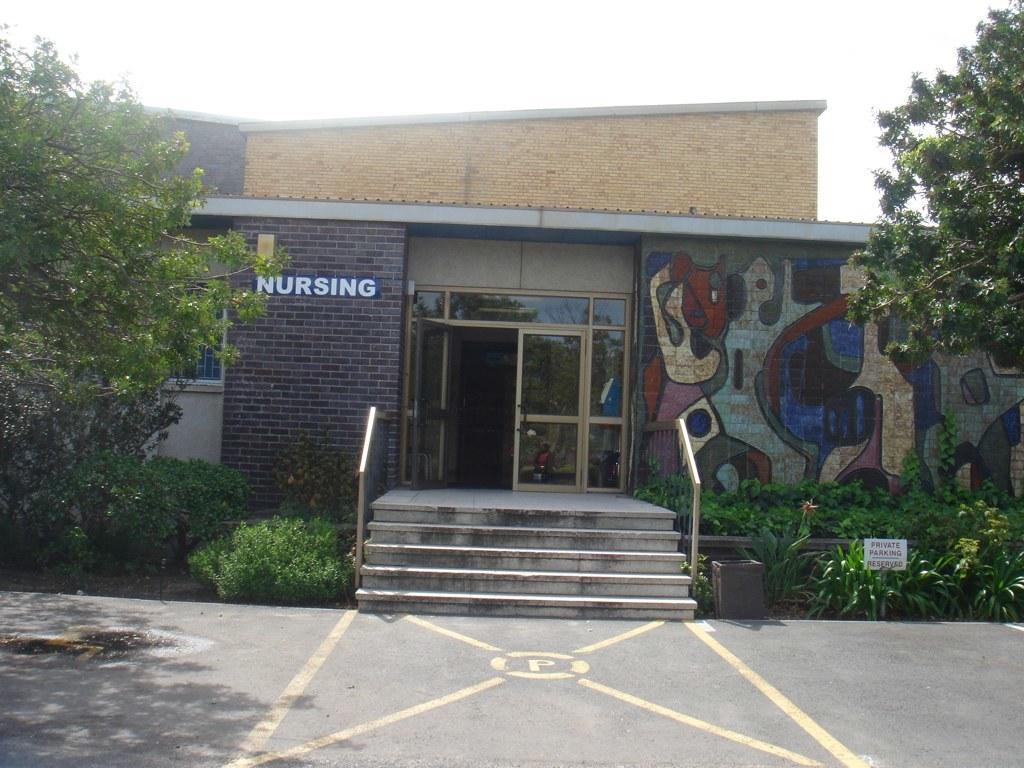Describe this image in one or two sentences. This picture is clicked outside. In the foreground we can see the ground. In the center we can see the plants, trees, staircase, handrails, door of the building and we can see the text and some pictures on the wall of the building. In the background we can see the sky. 